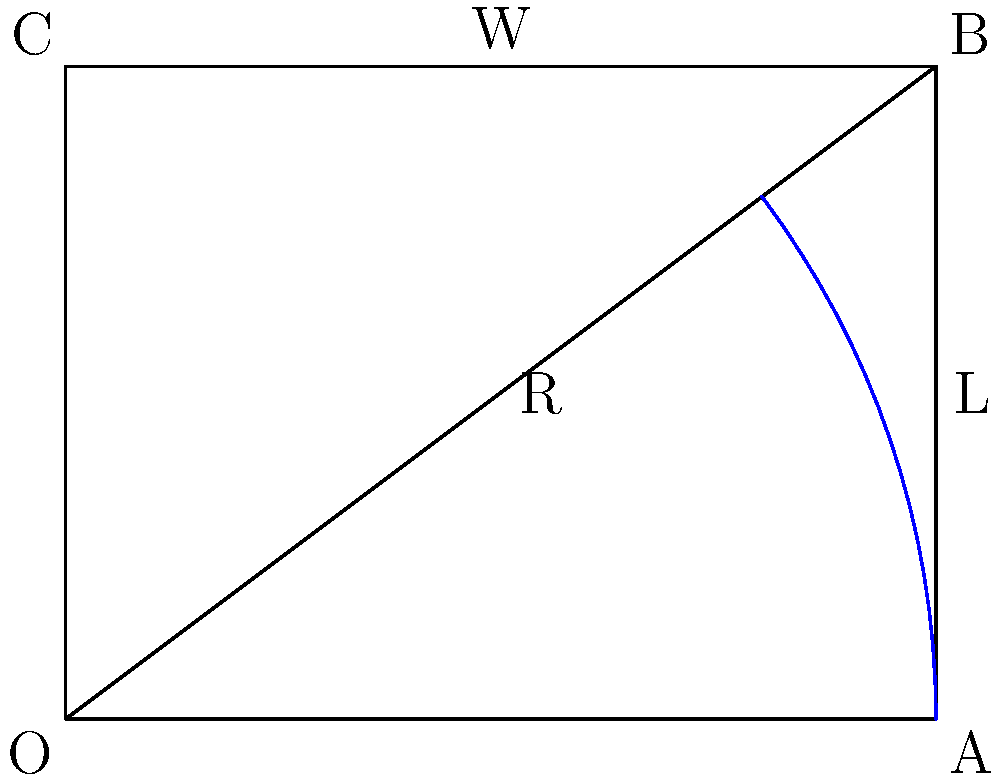A steam locomotive needs to navigate a curved section of track. The outer rail of the curve forms an arc with a radius of 100 meters. If the gauge (distance between the inner and outer rails) is 1.435 meters, and the locomotive's wheelbase (distance between the front and rear wheels) is 6 meters, calculate the minimum turning radius for the locomotive's center line. Round your answer to the nearest meter. Let's approach this step-by-step:

1) First, we need to understand what we're calculating. The minimum turning radius for the locomotive's center line will be between the radii of the outer and inner rails.

2) We're given:
   - Outer rail radius (R) = 100 meters
   - Gauge (W) = 1.435 meters
   - Wheelbase (L) = 6 meters

3) Let's find the inner rail radius:
   Inner rail radius = R - W = 100 - 1.435 = 98.565 meters

4) The center line of the locomotive will be halfway between the rails:
   Center line radius = R - (W/2) = 100 - (1.435/2) = 99.2825 meters

5) However, we need to account for the wheelbase. The rear wheels will have a larger turning radius than the front wheels due to the locomotive's length.

6) We can use the Pythagorean theorem to find this:
   $$(R + x)^2 = R^2 + L^2$$
   Where x is the additional radius needed.

7) Substituting our values:
   $$(99.2825 + x)^2 = 99.2825^2 + 6^2$$

8) Expanding:
   $$9856.99 + 198.565x + x^2 = 9856.99 + 36$$

9) Simplifying:
   $$x^2 + 198.565x - 36 = 0$$

10) This is a quadratic equation. We can solve it using the quadratic formula:
    $$x = \frac{-b \pm \sqrt{b^2 - 4ac}}{2a}$$
    Where a = 1, b = 198.565, and c = -36

11) Solving:
    $$x = \frac{-198.565 + \sqrt{198.565^2 - 4(1)(-36)}}{2(1)} \approx 0.1812$$

12) Therefore, the minimum turning radius is:
    99.2825 + 0.1812 = 99.4637 meters

13) Rounding to the nearest meter:
    99.4637 ≈ 99 meters
Answer: 99 meters 